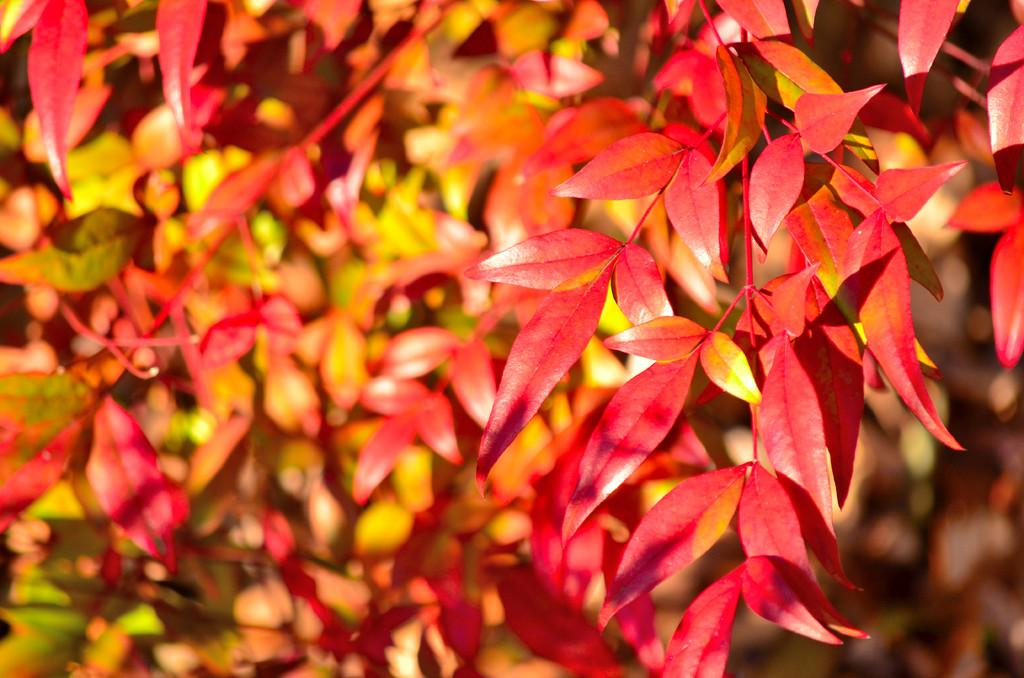What type of natural elements can be seen in the image? There are leaves in the image. What color are the leaves? The leaves are red in color. What type of writing can be seen on the leaves in the image? There is no writing present on the leaves in the image. 